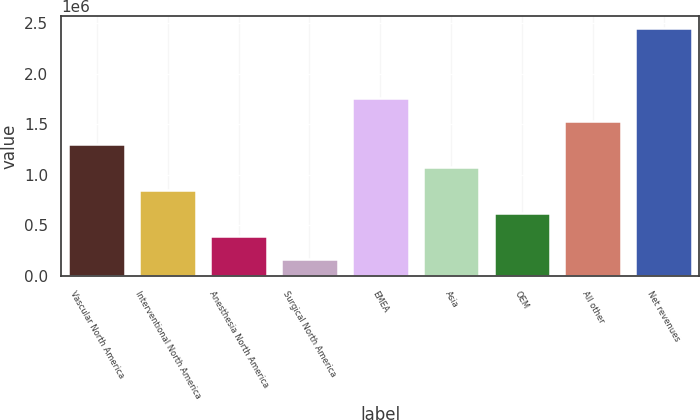Convert chart to OTSL. <chart><loc_0><loc_0><loc_500><loc_500><bar_chart><fcel>Vascular North America<fcel>Interventional North America<fcel>Anesthesia North America<fcel>Surgical North America<fcel>EMEA<fcel>Asia<fcel>OEM<fcel>All other<fcel>Net revenues<nl><fcel>1.30732e+06<fcel>850902<fcel>394479<fcel>166267<fcel>1.76375e+06<fcel>1.07911e+06<fcel>622690<fcel>1.53554e+06<fcel>2.44838e+06<nl></chart> 